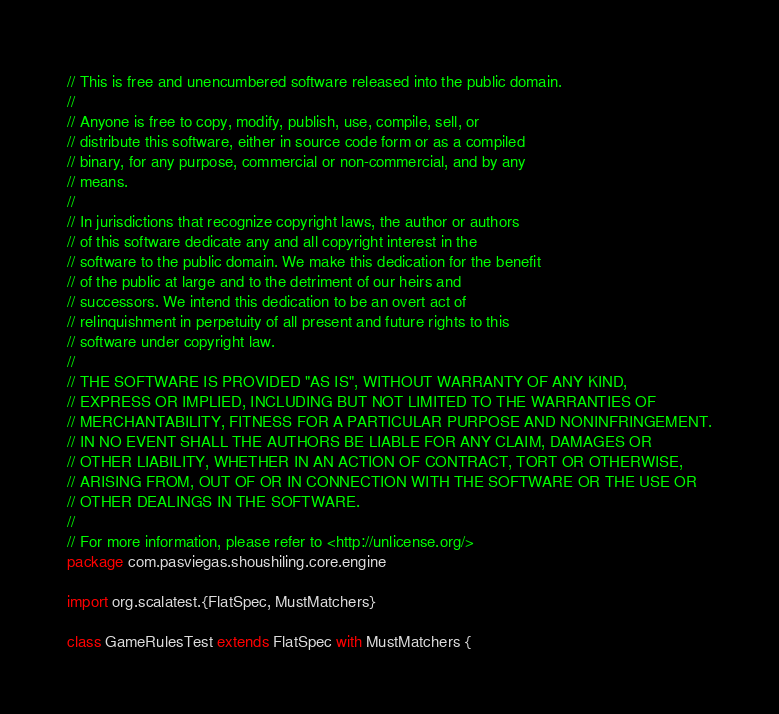Convert code to text. <code><loc_0><loc_0><loc_500><loc_500><_Scala_>// This is free and unencumbered software released into the public domain.
//
// Anyone is free to copy, modify, publish, use, compile, sell, or
// distribute this software, either in source code form or as a compiled
// binary, for any purpose, commercial or non-commercial, and by any
// means.
//
// In jurisdictions that recognize copyright laws, the author or authors
// of this software dedicate any and all copyright interest in the
// software to the public domain. We make this dedication for the benefit
// of the public at large and to the detriment of our heirs and
// successors. We intend this dedication to be an overt act of
// relinquishment in perpetuity of all present and future rights to this
// software under copyright law.
//
// THE SOFTWARE IS PROVIDED "AS IS", WITHOUT WARRANTY OF ANY KIND,
// EXPRESS OR IMPLIED, INCLUDING BUT NOT LIMITED TO THE WARRANTIES OF
// MERCHANTABILITY, FITNESS FOR A PARTICULAR PURPOSE AND NONINFRINGEMENT.
// IN NO EVENT SHALL THE AUTHORS BE LIABLE FOR ANY CLAIM, DAMAGES OR
// OTHER LIABILITY, WHETHER IN AN ACTION OF CONTRACT, TORT OR OTHERWISE,
// ARISING FROM, OUT OF OR IN CONNECTION WITH THE SOFTWARE OR THE USE OR
// OTHER DEALINGS IN THE SOFTWARE.
//
// For more information, please refer to <http://unlicense.org/>
package com.pasviegas.shoushiling.core.engine

import org.scalatest.{FlatSpec, MustMatchers}

class GameRulesTest extends FlatSpec with MustMatchers {
</code> 